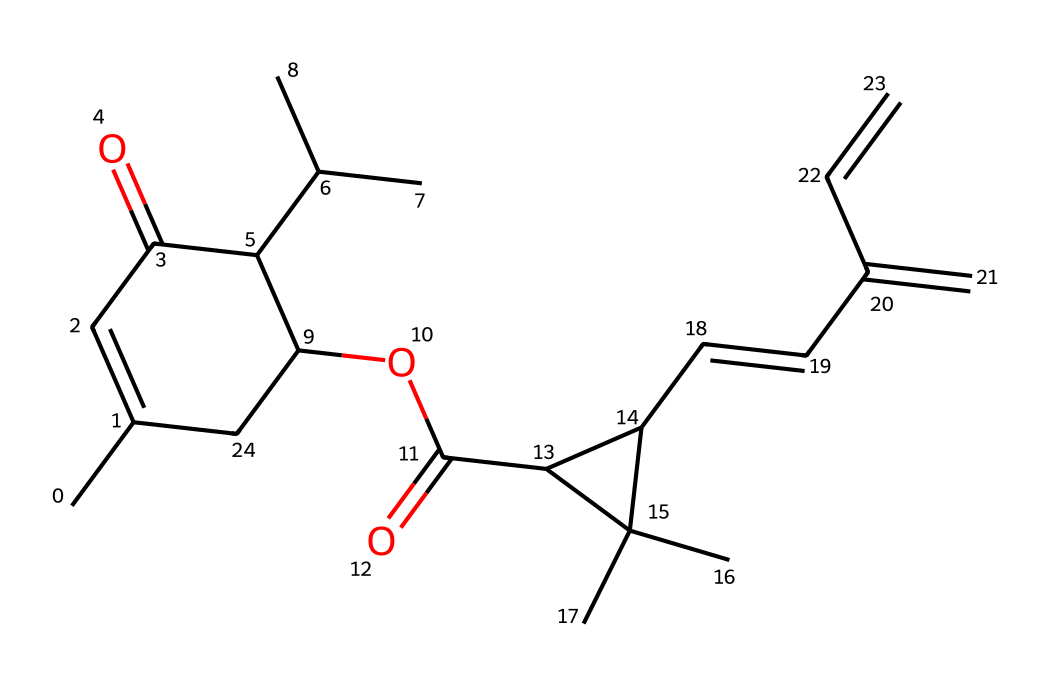What is the general formula of pyrethrin based on its SMILES structure? The SMILES representation indicates a complex organic structure typical of large natural compounds, suggesting a general formula that includes various carbon, hydrogen, and oxygen atoms. By analyzing the structure visually, it can be inferred that its formula fits the pattern for an organic compound with C, H, and O.
Answer: C22H28O5 How many rings are present in the molecular structure of pyrethrin? Upon examining the SMILES representation and the rendered chemical structure, we can identify the presence of two distinct cyclic arrangements, indicating the existence of two rings in the molecule.
Answer: 2 What functional groups are observable in this chemical structure? By analyzing the SMILES, we can identify functional groups such as carbonyl (C=O) and ester (C-O-C) present in the structure. These groups are indicated by the oxygen atoms connected to other carbon atoms and double-bonded oxygens.
Answer: carbonyl and ester What is the impact of the multiple substituent groups present in pyrethrin on its insecticidal properties? The presence of multiple branched alkyl groups increases the lipophilicity of pyrethrin, enhancing its ability to penetrate the insect exoskeleton, which is crucial for its efficacy as an insecticide.
Answer: increased lipophilicity What type of pesticide is pyrethrin classified as? Analyzing the structure and its mechanisms of action, it is clear that pyrethrin acts primarily on the nervous system of insects, classifying it as a neurotoxic pesticide.
Answer: neurotoxic What is the main source of pyrethrin in nature? By recognizing that pyrethrin is a natural insecticide derived from plants, we conclude that its primary source is chrysanthemum flowers, which produce pyrethrin as a defensive chemical.
Answer: chrysanthemum flowers What role do the isomeric forms play in the activity of pyrethrin? The structure of pyrethrin contains isomeric forms related to its stereochemistry, influencing its binding affinity to insect sodium channels and thus determining its effectiveness as an insecticide.
Answer: binding affinity to sodium channels 